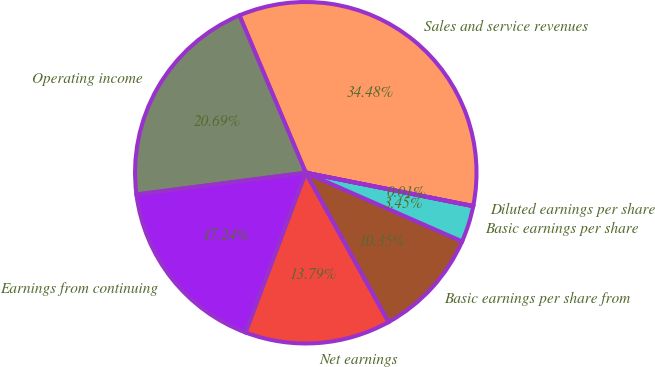Convert chart. <chart><loc_0><loc_0><loc_500><loc_500><pie_chart><fcel>Sales and service revenues<fcel>Operating income<fcel>Earnings from continuing<fcel>Net earnings<fcel>Basic earnings per share from<fcel>Basic earnings per share<fcel>Diluted earnings per share<nl><fcel>34.48%<fcel>20.69%<fcel>17.24%<fcel>13.79%<fcel>10.35%<fcel>3.45%<fcel>0.01%<nl></chart> 